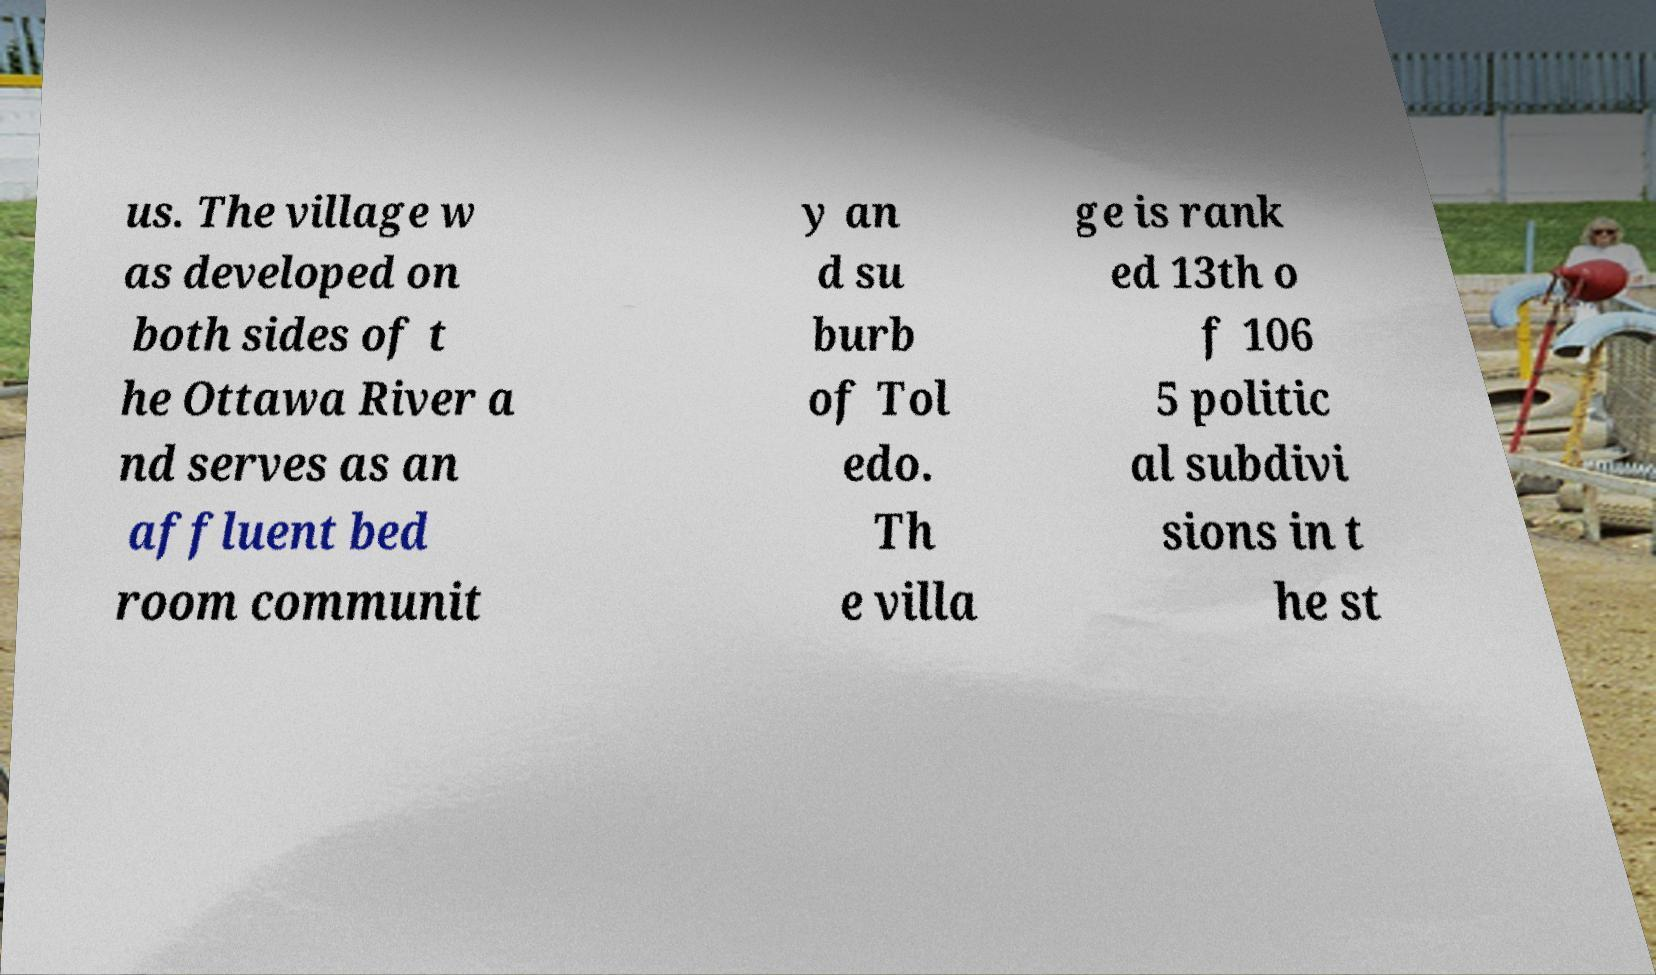For documentation purposes, I need the text within this image transcribed. Could you provide that? us. The village w as developed on both sides of t he Ottawa River a nd serves as an affluent bed room communit y an d su burb of Tol edo. Th e villa ge is rank ed 13th o f 106 5 politic al subdivi sions in t he st 